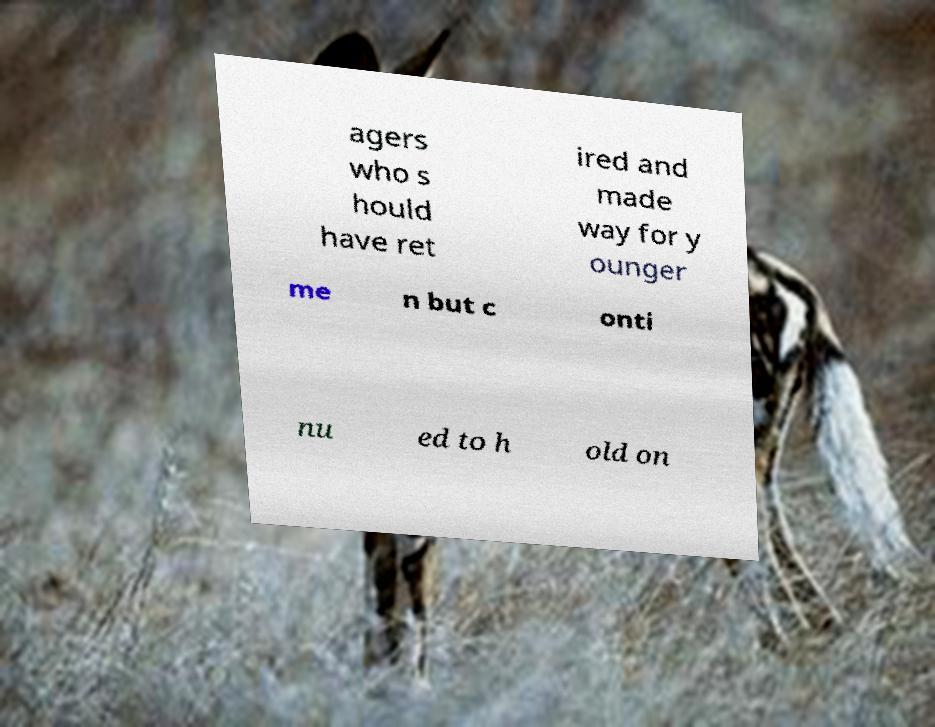Could you extract and type out the text from this image? agers who s hould have ret ired and made way for y ounger me n but c onti nu ed to h old on 